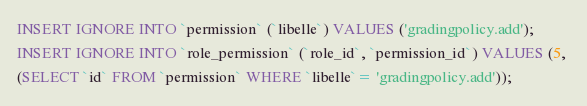Convert code to text. <code><loc_0><loc_0><loc_500><loc_500><_SQL_>INSERT IGNORE INTO `permission` (`libelle`) VALUES ('gradingpolicy.add');
INSERT IGNORE INTO `role_permission` (`role_id`, `permission_id`) VALUES (5, 
(SELECT `id` FROM `permission` WHERE `libelle`= 'gradingpolicy.add'));</code> 